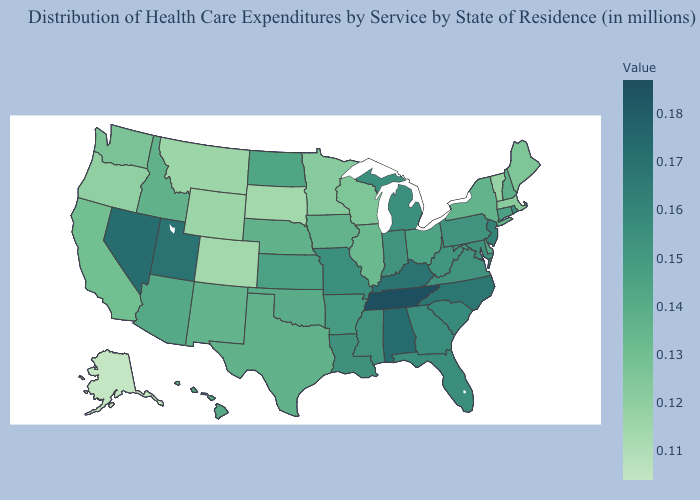Does North Dakota have the highest value in the USA?
Short answer required. No. Is the legend a continuous bar?
Keep it brief. Yes. Among the states that border Indiana , does Illinois have the lowest value?
Answer briefly. Yes. Among the states that border Illinois , does Kentucky have the lowest value?
Write a very short answer. No. 